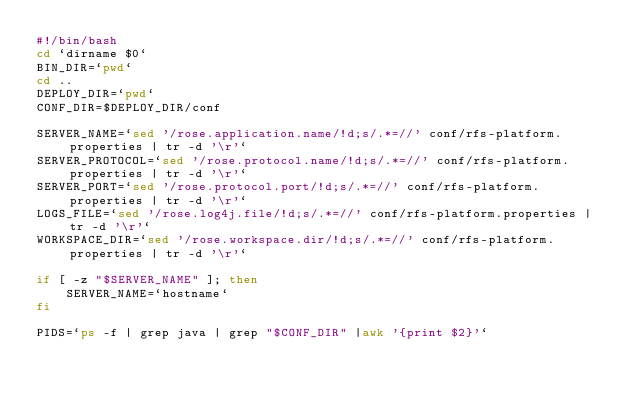Convert code to text. <code><loc_0><loc_0><loc_500><loc_500><_Bash_>#!/bin/bash
cd `dirname $0`
BIN_DIR=`pwd`
cd ..
DEPLOY_DIR=`pwd`
CONF_DIR=$DEPLOY_DIR/conf

SERVER_NAME=`sed '/rose.application.name/!d;s/.*=//' conf/rfs-platform.properties | tr -d '\r'`
SERVER_PROTOCOL=`sed '/rose.protocol.name/!d;s/.*=//' conf/rfs-platform.properties | tr -d '\r'`
SERVER_PORT=`sed '/rose.protocol.port/!d;s/.*=//' conf/rfs-platform.properties | tr -d '\r'`
LOGS_FILE=`sed '/rose.log4j.file/!d;s/.*=//' conf/rfs-platform.properties | tr -d '\r'`
WORKSPACE_DIR=`sed '/rose.workspace.dir/!d;s/.*=//' conf/rfs-platform.properties | tr -d '\r'`

if [ -z "$SERVER_NAME" ]; then
    SERVER_NAME=`hostname`
fi

PIDS=`ps -f | grep java | grep "$CONF_DIR" |awk '{print $2}'`</code> 